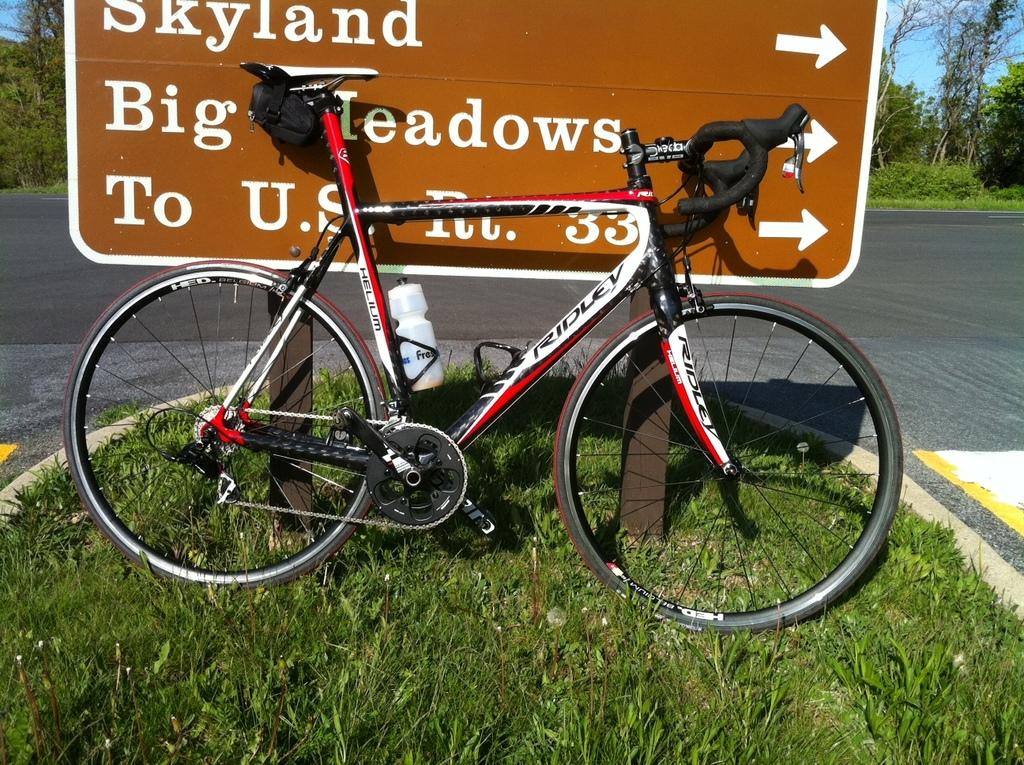What object is placed on the grass in the image? There is a bicycle on the grass. What is located beside the bicycle? There is a board with text beside the bicycle. What can be seen in the background of the image? There is a road and trees in the background of the image. What part of the natural environment is visible in the image? The sky is visible in the background of the image. What type of bat is flying over the bicycle in the image? There is no bat present in the image; it only features a bicycle, a board with text, and the background elements. 